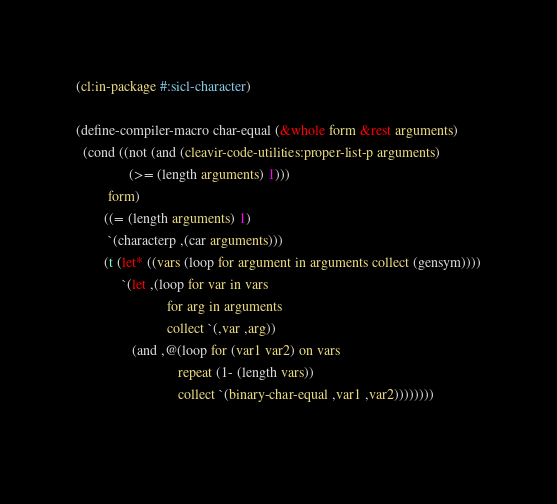<code> <loc_0><loc_0><loc_500><loc_500><_Lisp_>(cl:in-package #:sicl-character)

(define-compiler-macro char-equal (&whole form &rest arguments)
  (cond ((not (and (cleavir-code-utilities:proper-list-p arguments)
               (>= (length arguments) 1)))
         form)
        ((= (length arguments) 1)
         `(characterp ,(car arguments)))
        (t (let* ((vars (loop for argument in arguments collect (gensym))))
             `(let ,(loop for var in vars
                          for arg in arguments
                          collect `(,var ,arg))
                (and ,@(loop for (var1 var2) on vars
                             repeat (1- (length vars))
                             collect `(binary-char-equal ,var1 ,var2))))))))
 
</code> 